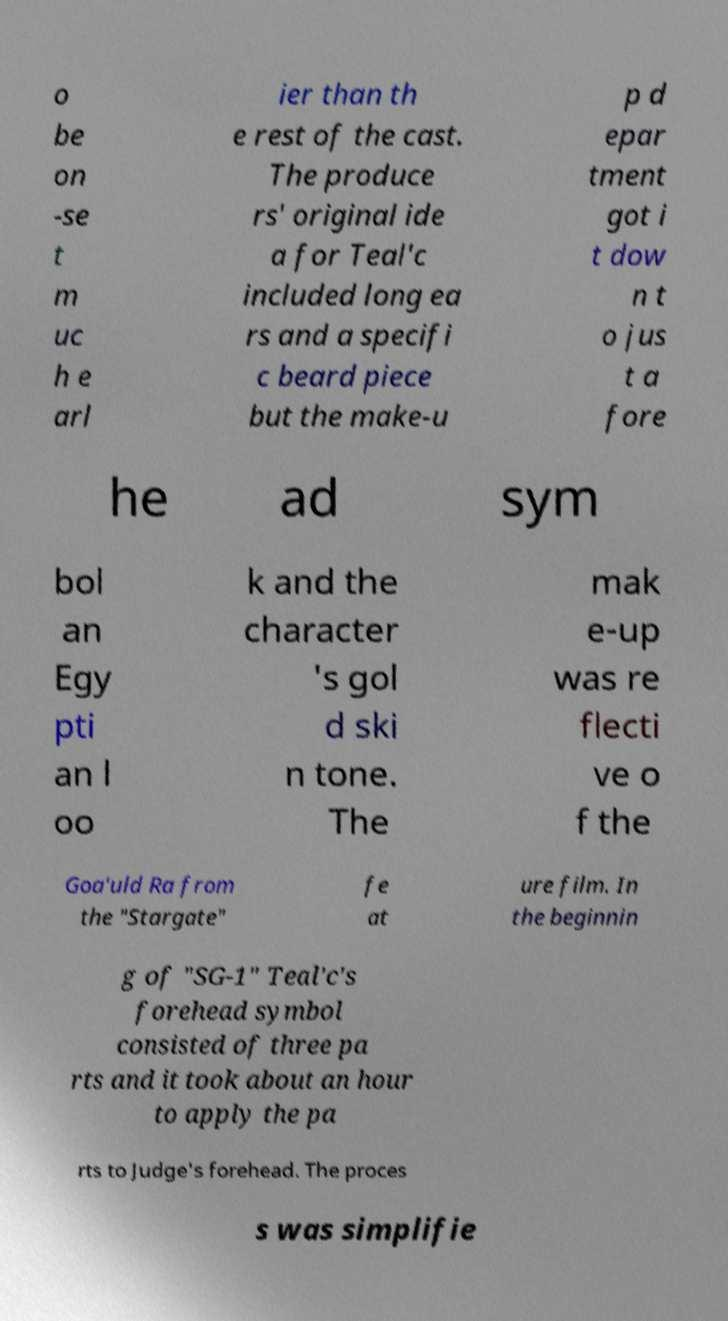I need the written content from this picture converted into text. Can you do that? o be on -se t m uc h e arl ier than th e rest of the cast. The produce rs' original ide a for Teal'c included long ea rs and a specifi c beard piece but the make-u p d epar tment got i t dow n t o jus t a fore he ad sym bol an Egy pti an l oo k and the character 's gol d ski n tone. The mak e-up was re flecti ve o f the Goa'uld Ra from the "Stargate" fe at ure film. In the beginnin g of "SG-1" Teal'c's forehead symbol consisted of three pa rts and it took about an hour to apply the pa rts to Judge's forehead. The proces s was simplifie 